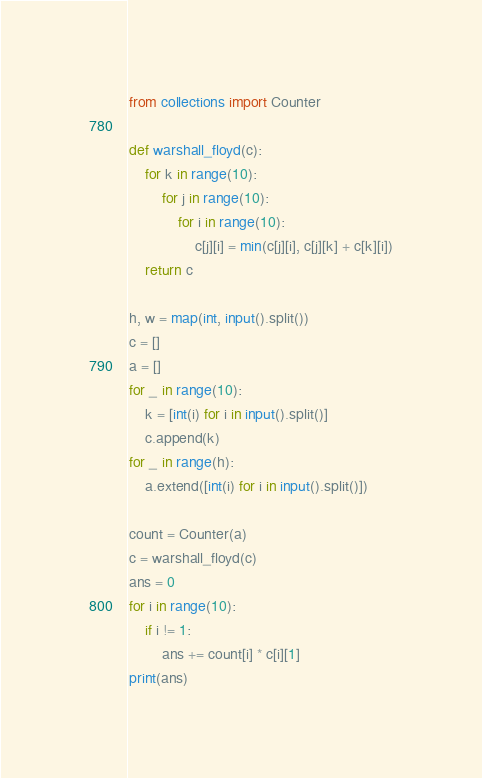Convert code to text. <code><loc_0><loc_0><loc_500><loc_500><_Python_>from collections import Counter

def warshall_floyd(c):
    for k in range(10):
        for j in range(10):
            for i in range(10):
                c[j][i] = min(c[j][i], c[j][k] + c[k][i])
    return c

h, w = map(int, input().split())
c = []
a = []
for _ in range(10):
    k = [int(i) for i in input().split()]
    c.append(k)
for _ in range(h):
    a.extend([int(i) for i in input().split()])

count = Counter(a)
c = warshall_floyd(c)
ans = 0
for i in range(10):
    if i != 1:
        ans += count[i] * c[i][1]
print(ans)
</code> 